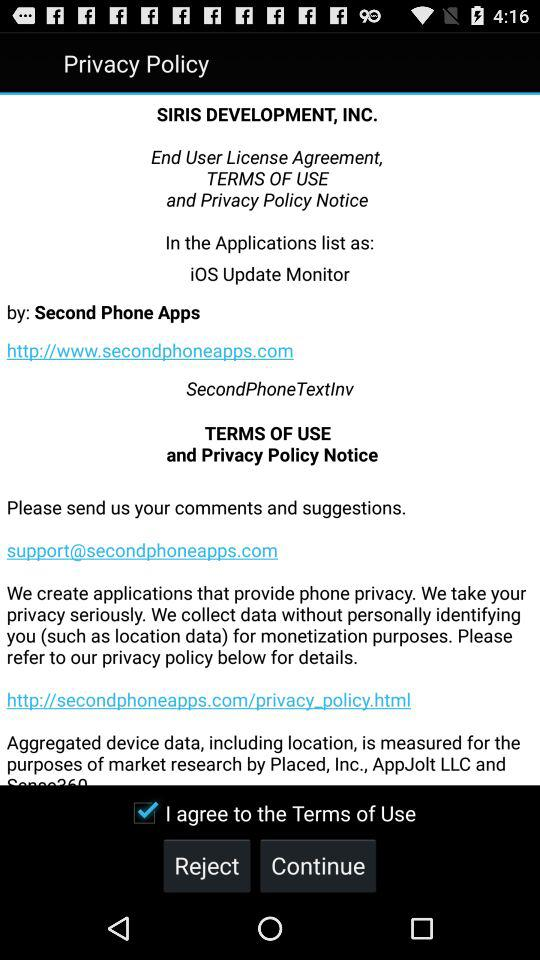What is the email address to submit comments and suggestions? The email address is support@secondphoneapps.com. 